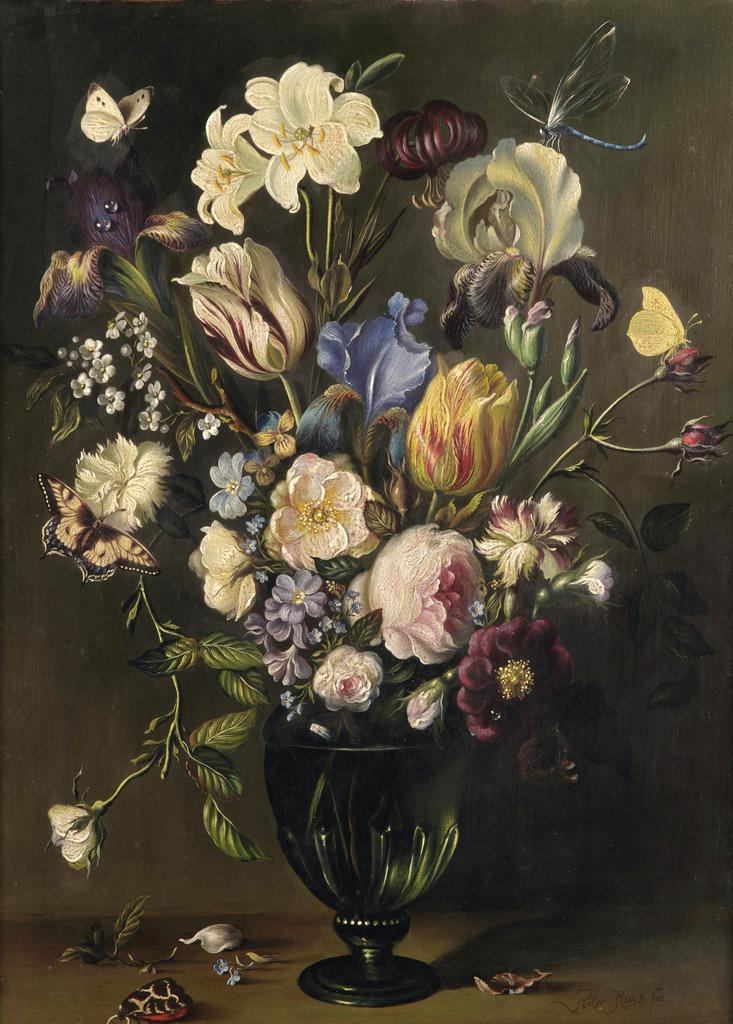What is featured in the image? There is a poster in the image. What is depicted in the center of the poster? There is a flower vase in the middle of the poster. What types of plants are shown in the poster? There are flowers and leaves in the poster. Are there any animals in the poster? Yes, there are butterflies in the poster. Where are the leaves located in the poster? There are leaves at the bottom of the poster. Can you tell me how many houses are visible in the poster? There are no houses depicted in the poster; it features a flower vase, flowers, leaves, and butterflies. What type of book is the person reading in the poster? There is no person reading a book in the poster; it is a still image of a flower vase, flowers, leaves, and butterflies. 